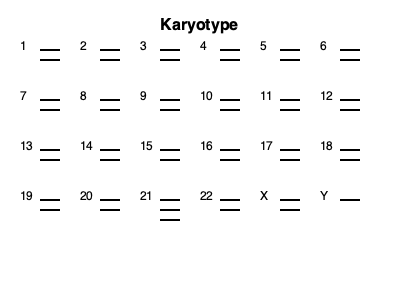Based on the karyotype diagram provided, which chromosomal abnormality is present, and what condition does it indicate? To identify the chromosomal abnormality and the associated condition, we need to analyze the karyotype diagram step-by-step:

1. A normal human karyotype contains 23 pairs of chromosomes, for a total of 46 chromosomes.

2. In this karyotype, we can see that all chromosome pairs from 1 to 20 and 22 appear normal, with two copies each.

3. The sex chromosomes (X and Y) also appear normal, indicating this is a male karyotype.

4. However, when we look at chromosome 21, we can see three copies instead of the usual two.

5. The presence of an extra copy of chromosome 21 is known as Trisomy 21.

6. Trisomy 21 is the genetic cause of Down syndrome, a condition characterized by intellectual disability, distinctive facial features, and various health issues.

7. Down syndrome occurs in approximately 1 in 700 live births and is one of the most common chromosomal abnormalities.

8. The risk of having a child with Down syndrome increases with maternal age, which is why prenatal screening and diagnostic tests are often recommended for pregnant women, especially those over 35 years of age.

Therefore, the chromosomal abnormality present in this karyotype is Trisomy 21, indicating Down syndrome.
Answer: Trisomy 21 (Down syndrome) 